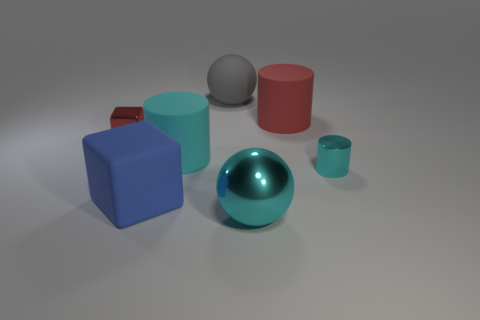Relative to their sizes, how do these objects compare to one another? The sizes of the objects vary. The blue cube and gray sphere are large, with the blue cube having a distinctly defined size due to its edges and corners. The teal cylinder and red cube are medium-sized, while the blue sphere is notably large and shiny, indicating a significant volume. Lastly, the small teal cup is the smallest object in the scene. 